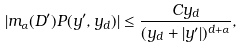Convert formula to latex. <formula><loc_0><loc_0><loc_500><loc_500>| m _ { \alpha } ( D ^ { \prime } ) P ( y ^ { \prime } , y _ { d } ) | \leq \frac { C y _ { d } } { ( y _ { d } + | y ^ { \prime } | ) ^ { d + \alpha } } ,</formula> 